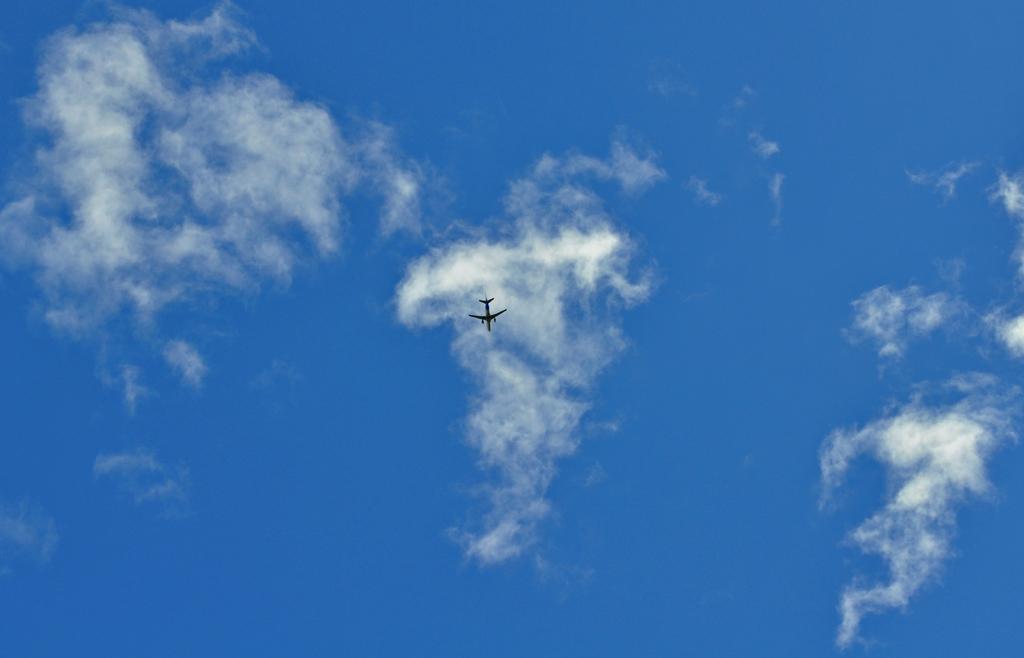Can you describe this image briefly? In the center of the image we can see an airplane flying in the sky. The sky looks cloudy. 